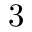<formula> <loc_0><loc_0><loc_500><loc_500>3</formula> 